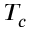Convert formula to latex. <formula><loc_0><loc_0><loc_500><loc_500>T _ { c }</formula> 